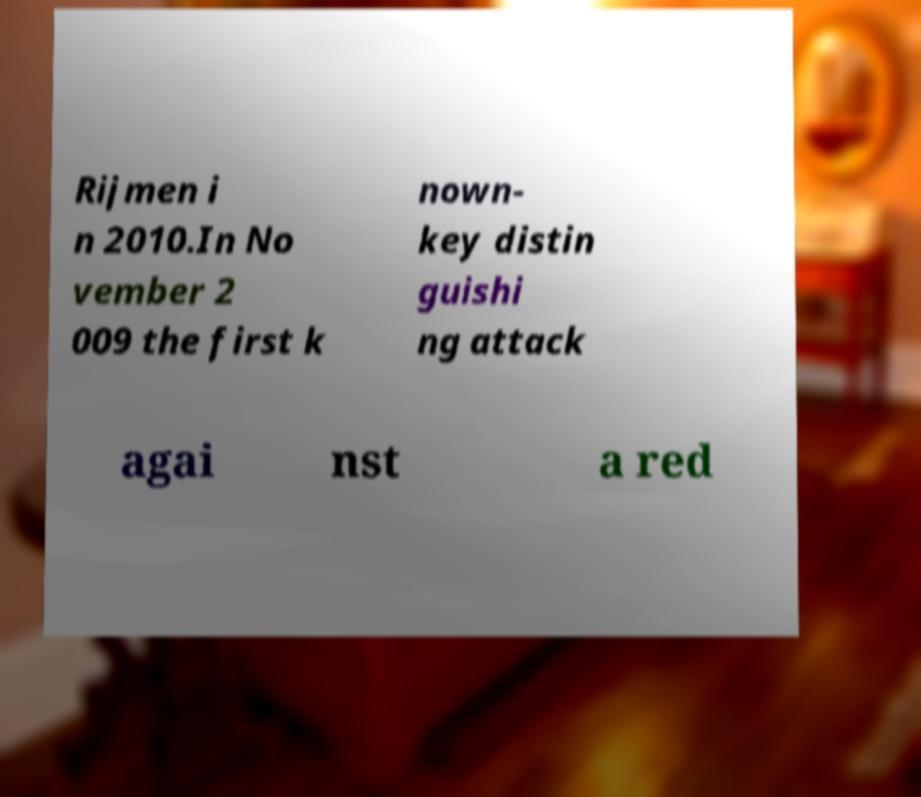Could you extract and type out the text from this image? Rijmen i n 2010.In No vember 2 009 the first k nown- key distin guishi ng attack agai nst a red 